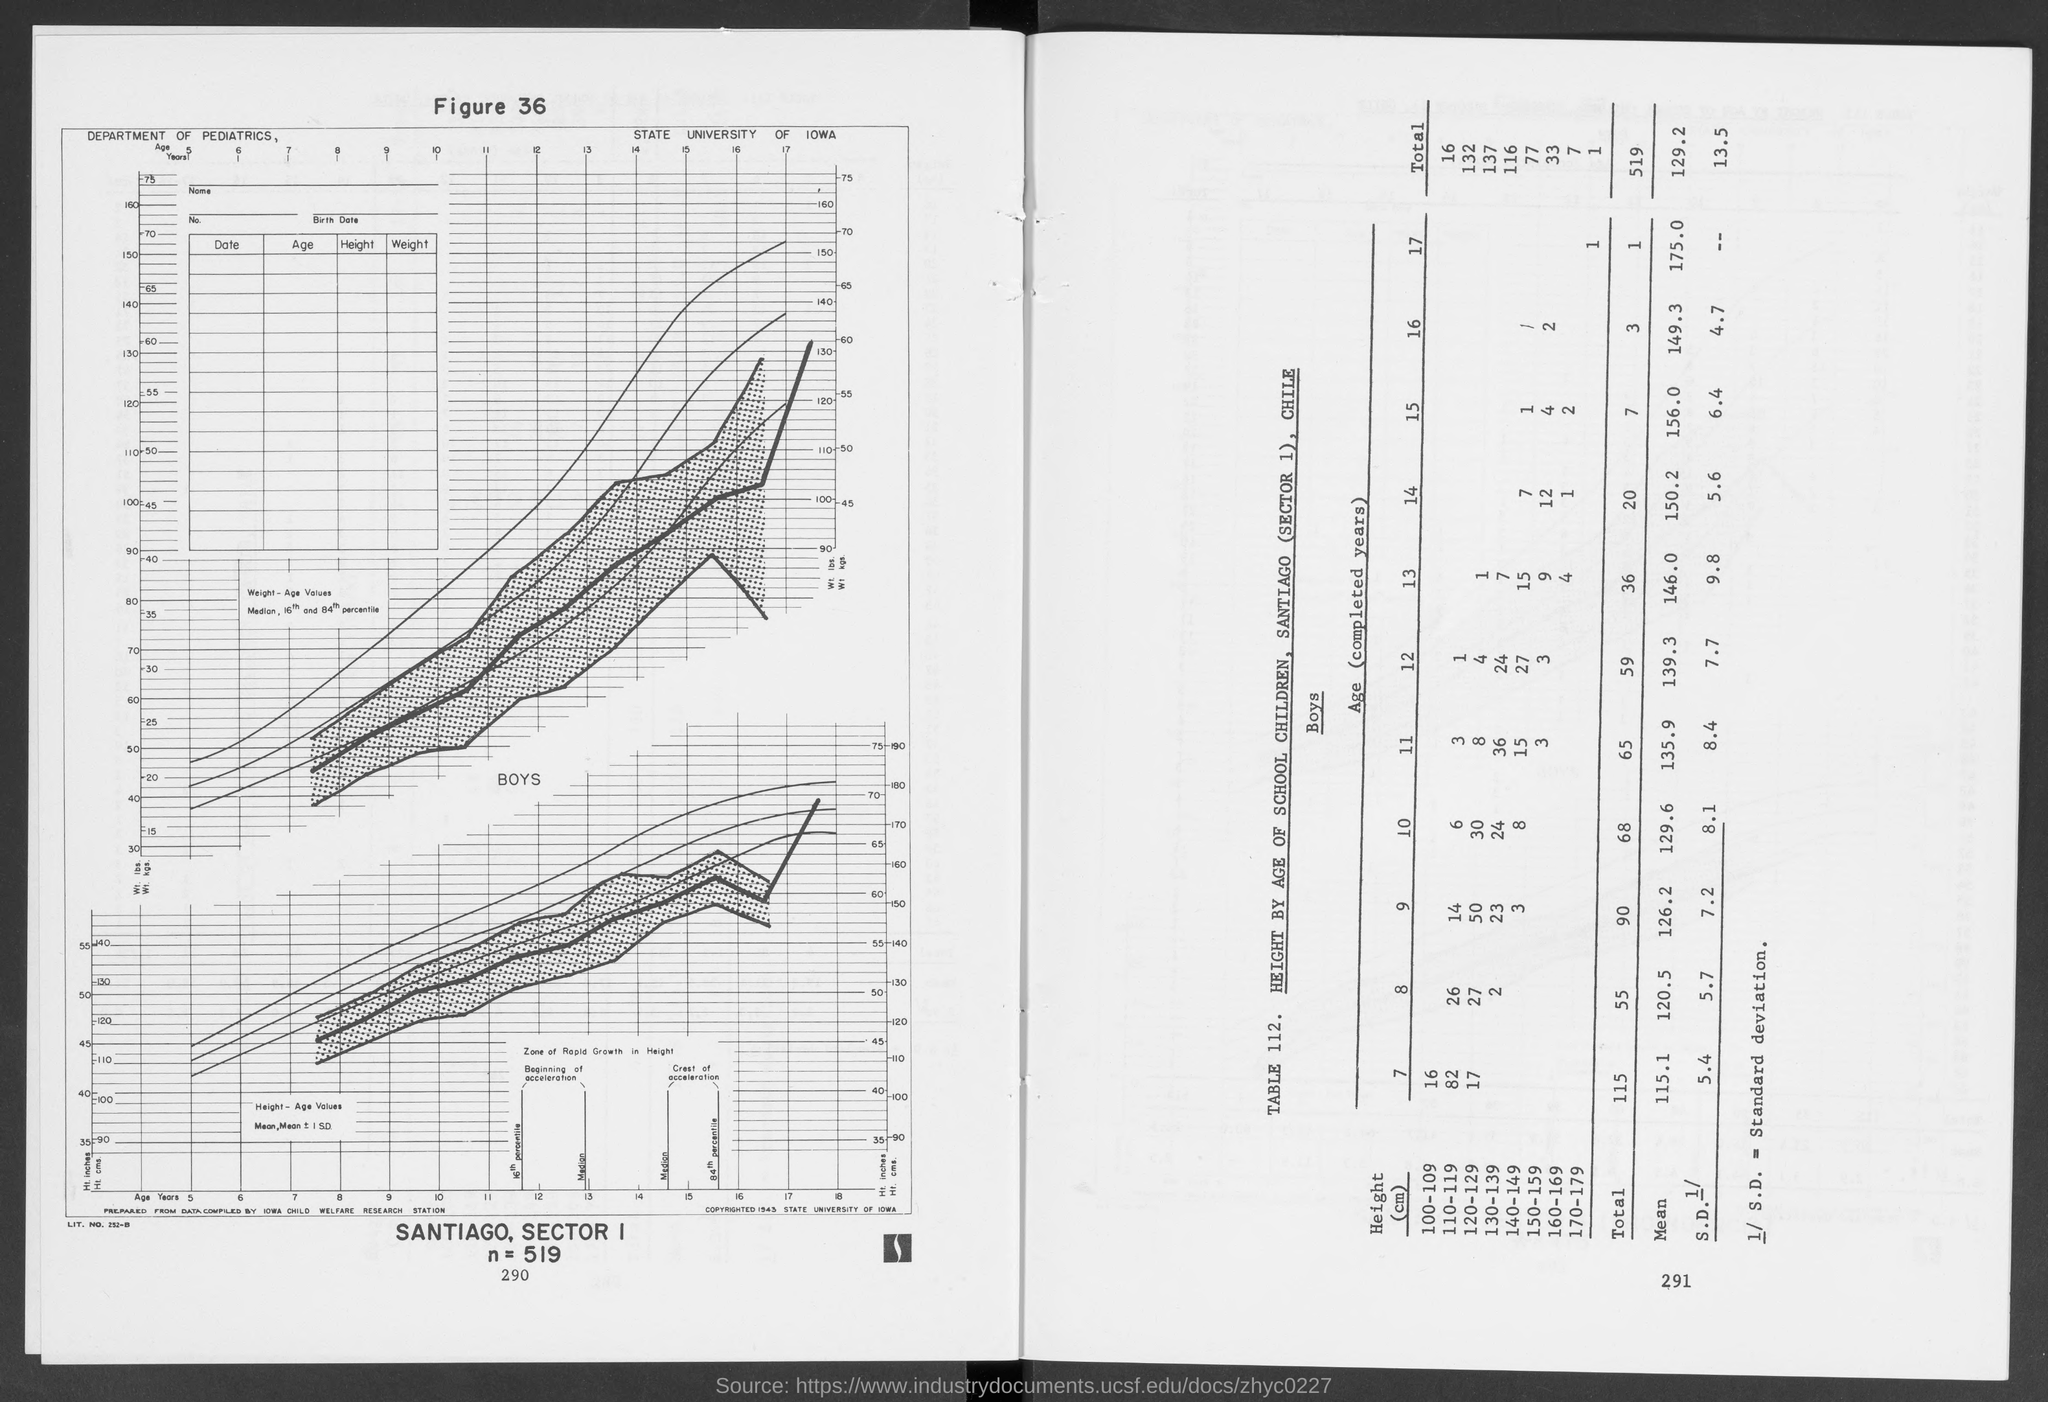Specify some key components in this picture. Standard Deviation is a statistical measure that represents the amount of variation or dispersion in a set of data. The question asks about the range of heights that has the maximum number of children. The number of children of the age of 7 who have a height in the range of 100-109 is 16. It is uncertain which range of height has the minimum number of children. The value of n is 519, as stated in the declaration. 